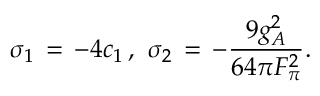<formula> <loc_0><loc_0><loc_500><loc_500>\sigma _ { 1 } \, = \, - 4 c _ { 1 } \, , \ \sigma _ { 2 } \, = \, - \frac { 9 g _ { A } ^ { 2 } } { 6 4 \pi F _ { \pi } ^ { 2 } } .</formula> 